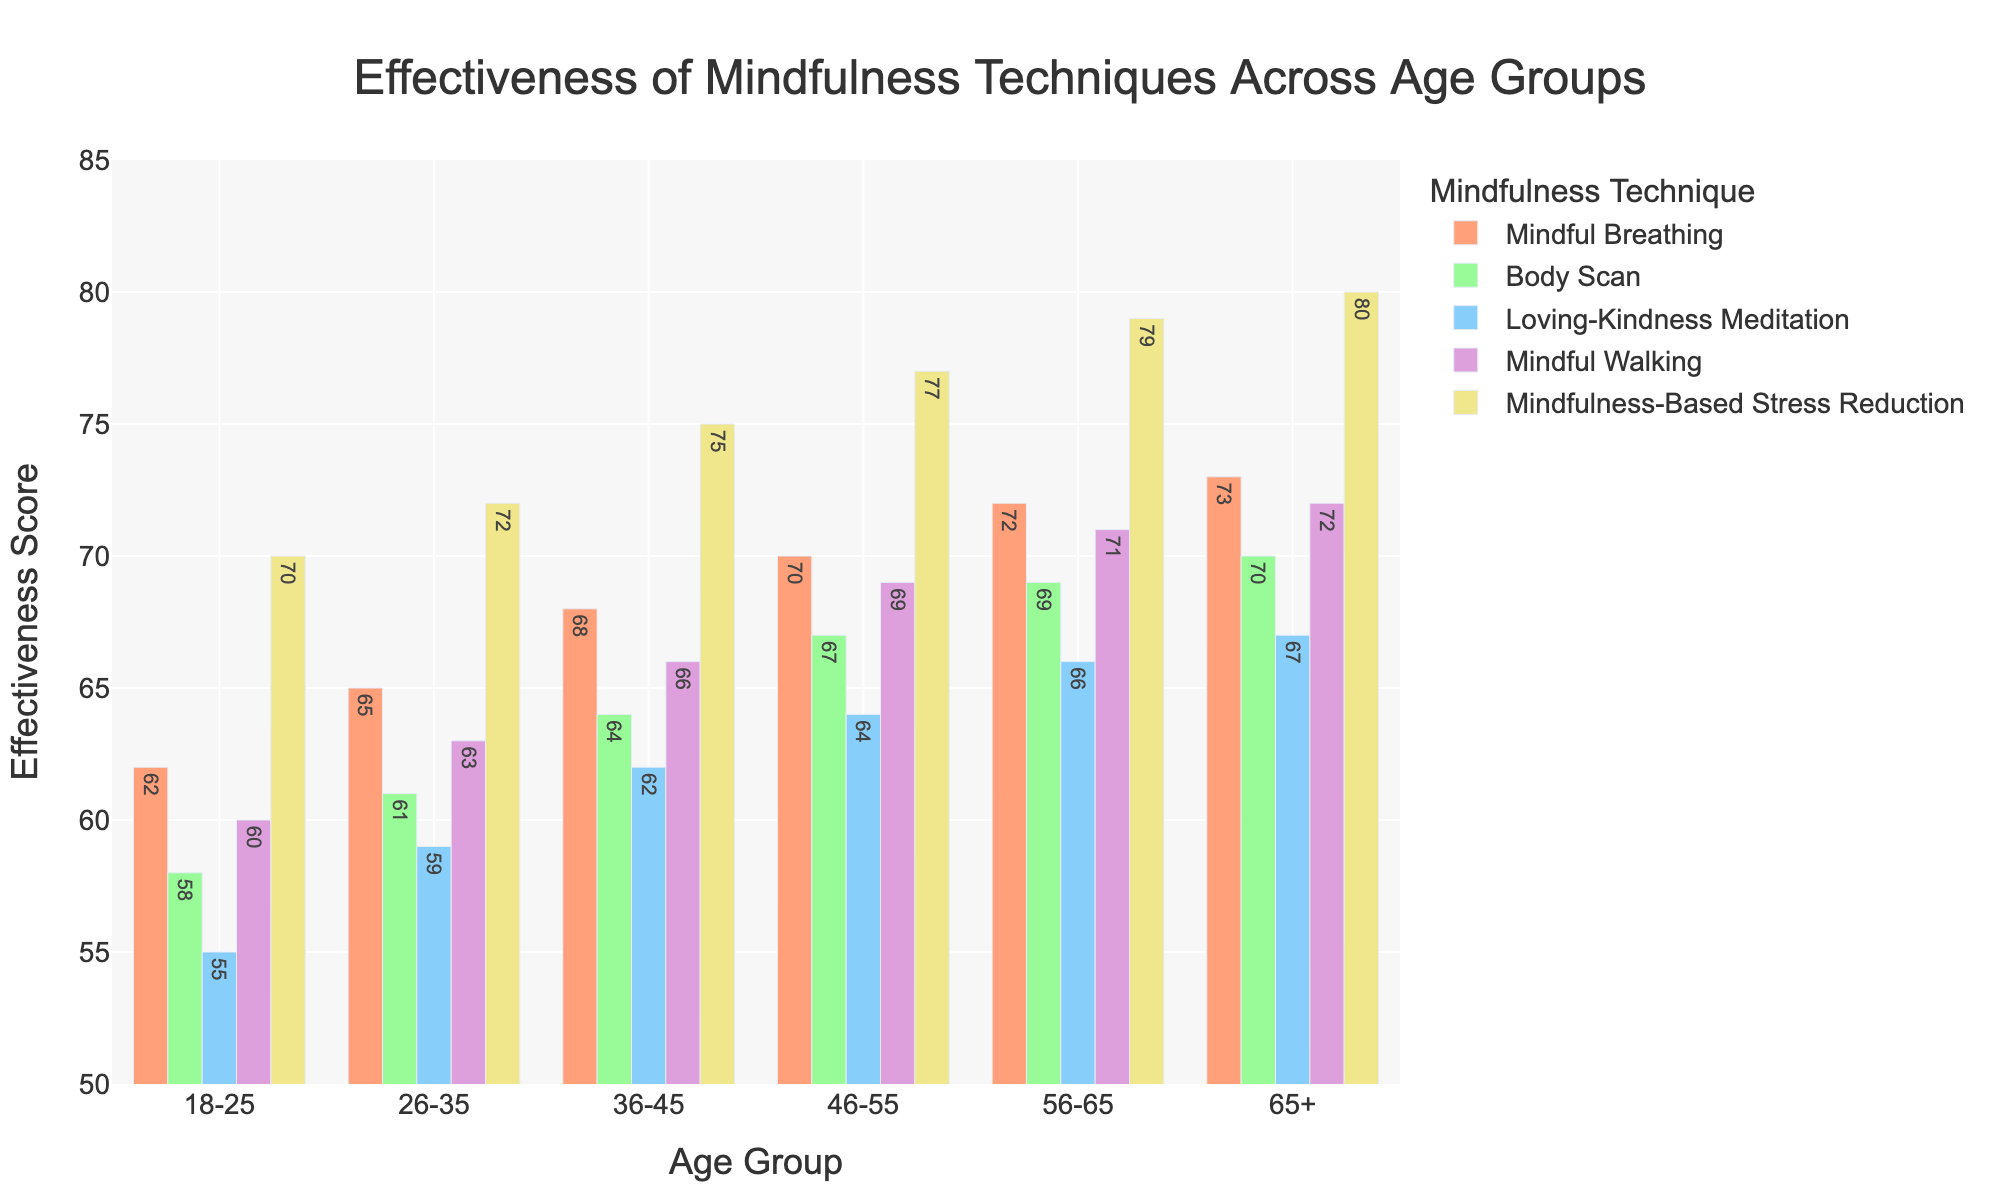What's the most effective mindfulness technique for the 26-35 age group? Look at the figure for the 26-35 age group. The highest bar is for Mindfulness-Based Stress Reduction with a height of 72, indicating it is the most effective technique for that age group.
Answer: Mindfulness-Based Stress Reduction Which age group finds Mindful Breathing the most effective? Compare the bars for Mindful Breathing across all age groups. The highest bar is for the 65+ age group with a height of 73.
Answer: 65+ How much more effective is Mindful Walking compared to Body Scan for the 46-55 age group? For the 46-55 age group, the effectiveness score of Mindful Walking is 69, and the score for Body Scan is 67. Subtract 67 from 69 to find the difference.
Answer: 2 For the 36-45 age group, which mindfulness technique is the least effective? Look at the figure for the 36-45 age group and compare all techniques. The lowest bar is for Loving-Kindness Meditation with a height of 62.
Answer: Loving-Kindness Meditation What is the average effectiveness score of all mindfulness techniques for the 56-65 age group? For the 56-65 age group, sum the effectiveness scores (72 + 69 + 66 + 71 + 79) which equals 357. There are 5 techniques, so divide 357 by 5 to get the average.
Answer: 71.4 Which age group shows the greatest effectiveness of Loving-Kindness Meditation? Compare the bars for Loving-Kindness Meditation across all age groups. The highest bar is for the 65+ age group with a height of 67.
Answer: 65+ What is the combined effectiveness score of Body Scan and Mindful Breathing for the 18-25 age group? For the 18-25 age group, the effectiveness score for Body Scan is 58 and for Mindful Breathing is 62. Adding these two scores gives 58 + 62 = 120.
Answer: 120 Which mindfulness technique shows a consistent increase in effectiveness across all age groups? By examining the trends across age groups, Mindfulness-Based Stress Reduction shows a consistent increase from 70 to 80, indicating a continuous rise for all age groups.
Answer: Mindfulness-Based Stress Reduction 